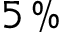Convert formula to latex. <formula><loc_0><loc_0><loc_500><loc_500>5 \, \%</formula> 